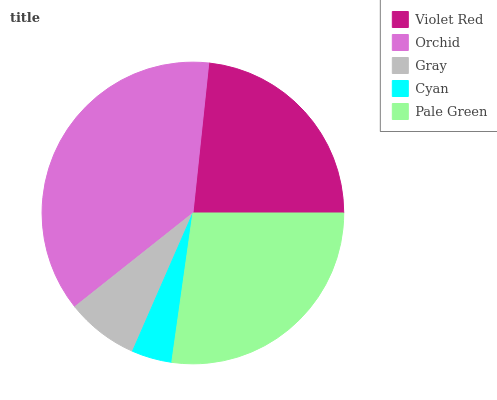Is Cyan the minimum?
Answer yes or no. Yes. Is Orchid the maximum?
Answer yes or no. Yes. Is Gray the minimum?
Answer yes or no. No. Is Gray the maximum?
Answer yes or no. No. Is Orchid greater than Gray?
Answer yes or no. Yes. Is Gray less than Orchid?
Answer yes or no. Yes. Is Gray greater than Orchid?
Answer yes or no. No. Is Orchid less than Gray?
Answer yes or no. No. Is Violet Red the high median?
Answer yes or no. Yes. Is Violet Red the low median?
Answer yes or no. Yes. Is Cyan the high median?
Answer yes or no. No. Is Gray the low median?
Answer yes or no. No. 